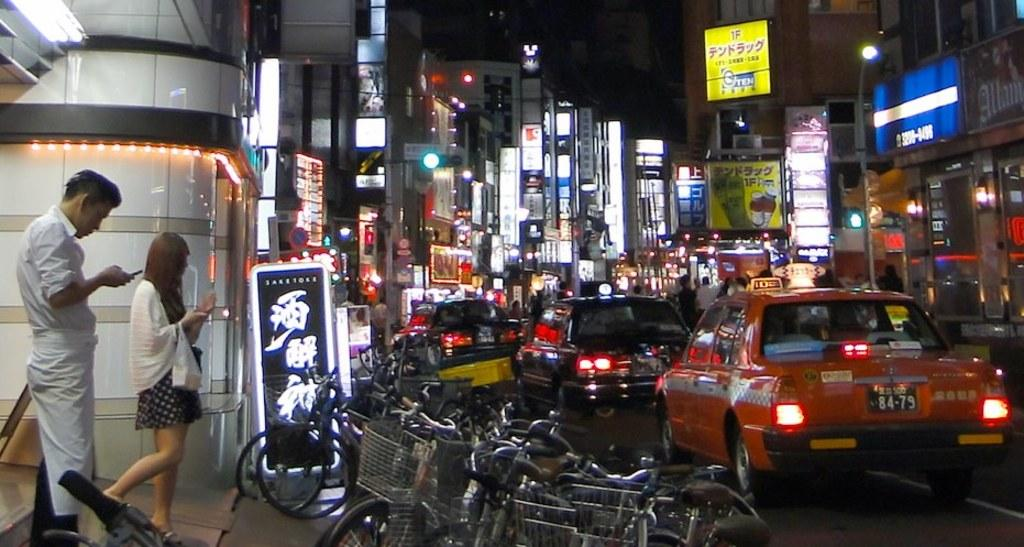Provide a one-sentence caption for the provided image. Very busy Asian down town area, full of shop and cars with many bill boards in Asian characteristics. 